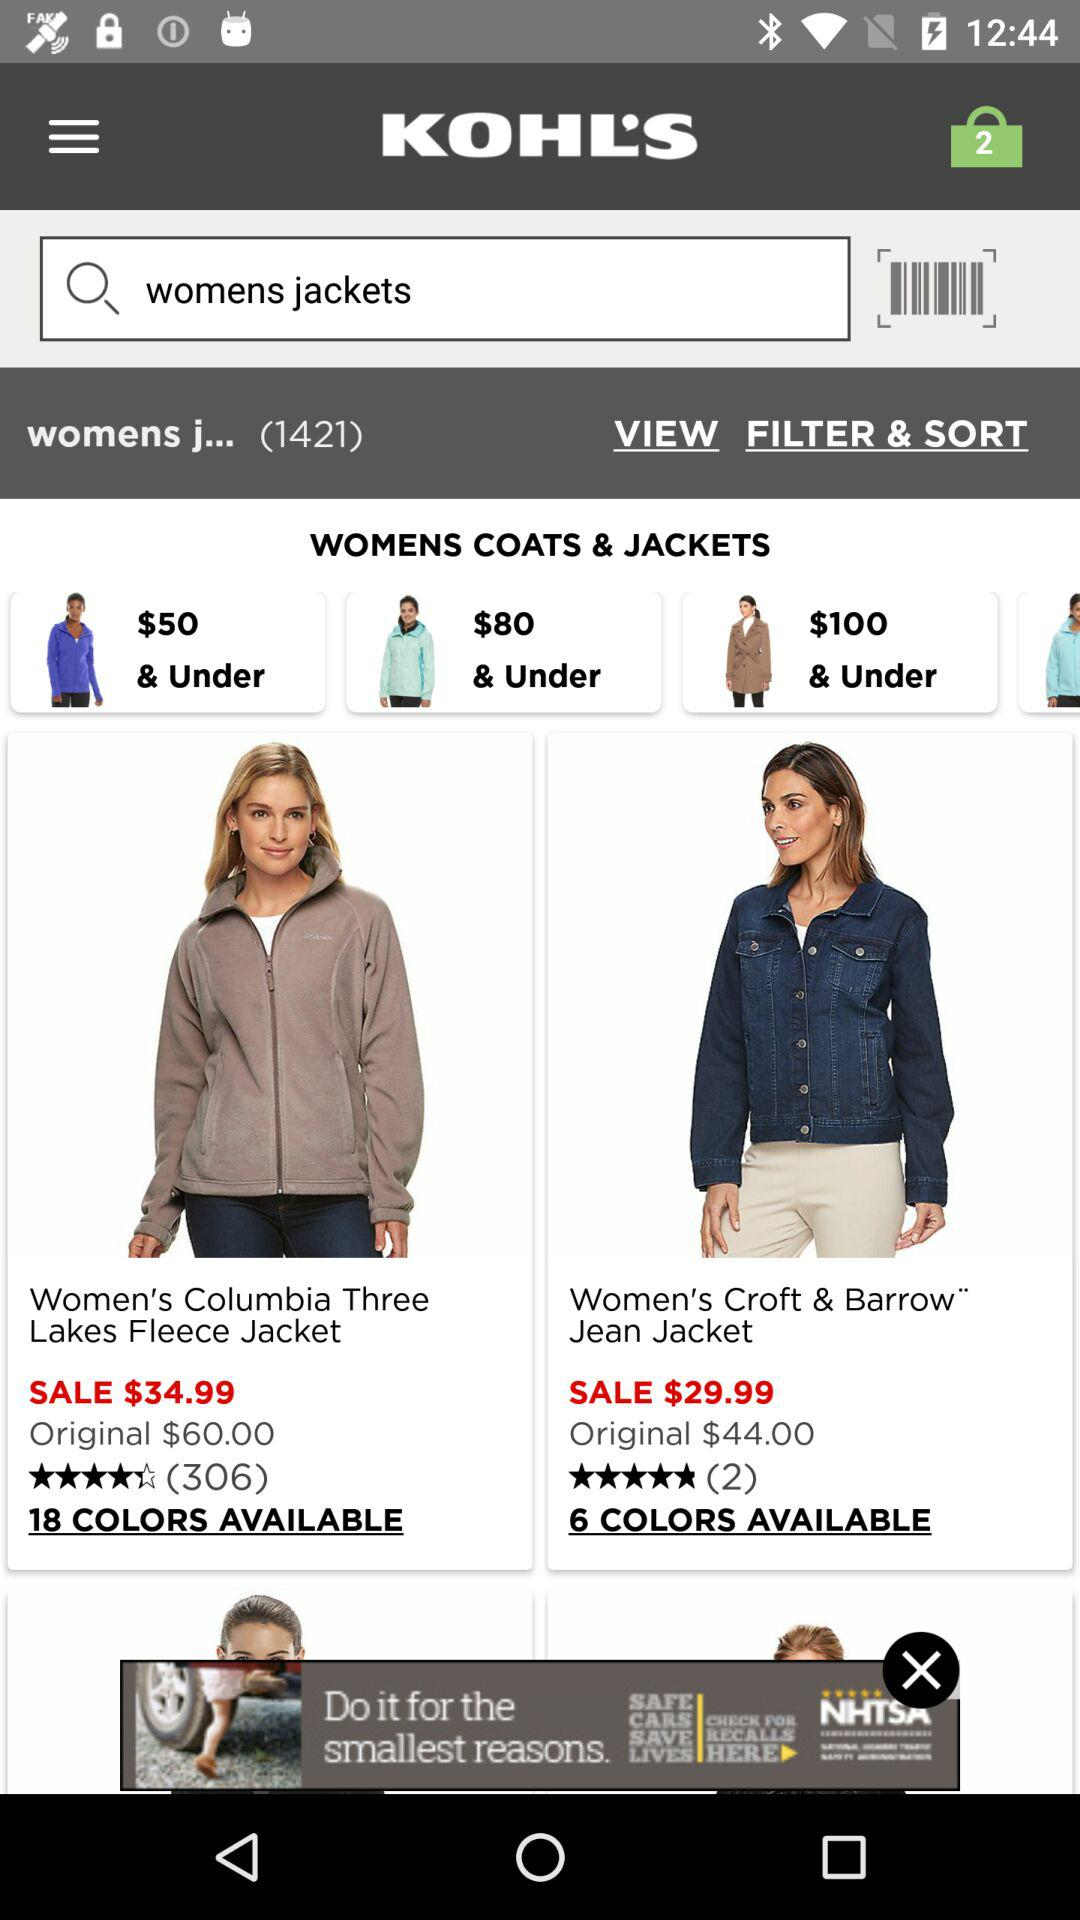What is the original price of the women's Columbia jacket? The original price is $60.00. 